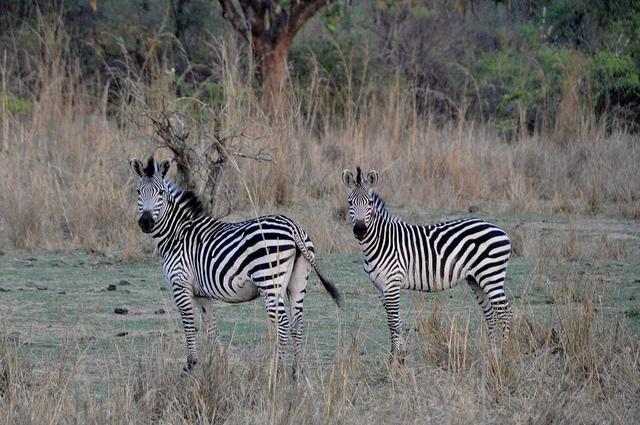What other animal closely resembles these?
Quick response, please. Horse. Are the animals facing the same direction?
Give a very brief answer. Yes. What are the animals standing in?
Give a very brief answer. Grass. Are the zebras a male or female?
Be succinct. Female. What habitat are these animals in?
Write a very short answer. Wild. Are the zebras eating grass?
Give a very brief answer. No. Which direction are the zebras facing?
Keep it brief. Left. 